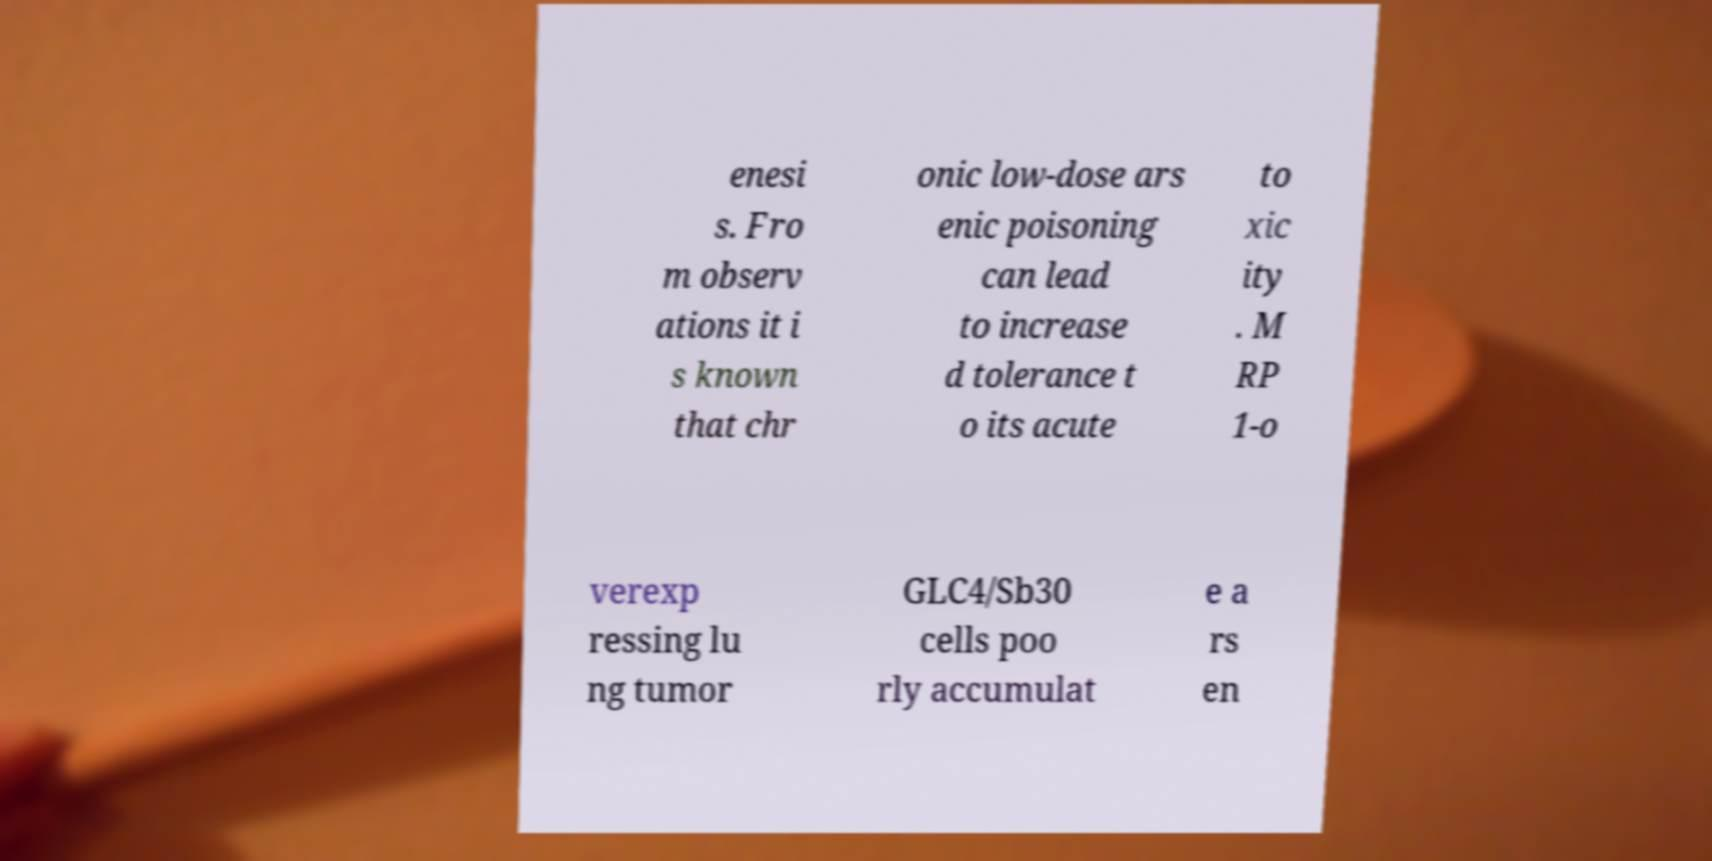Could you extract and type out the text from this image? enesi s. Fro m observ ations it i s known that chr onic low-dose ars enic poisoning can lead to increase d tolerance t o its acute to xic ity . M RP 1-o verexp ressing lu ng tumor GLC4/Sb30 cells poo rly accumulat e a rs en 